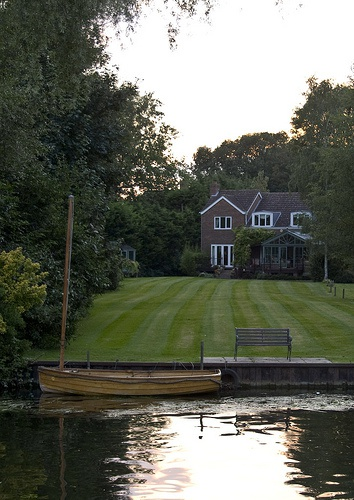Describe the objects in this image and their specific colors. I can see boat in black and gray tones and bench in black, gray, and darkgreen tones in this image. 